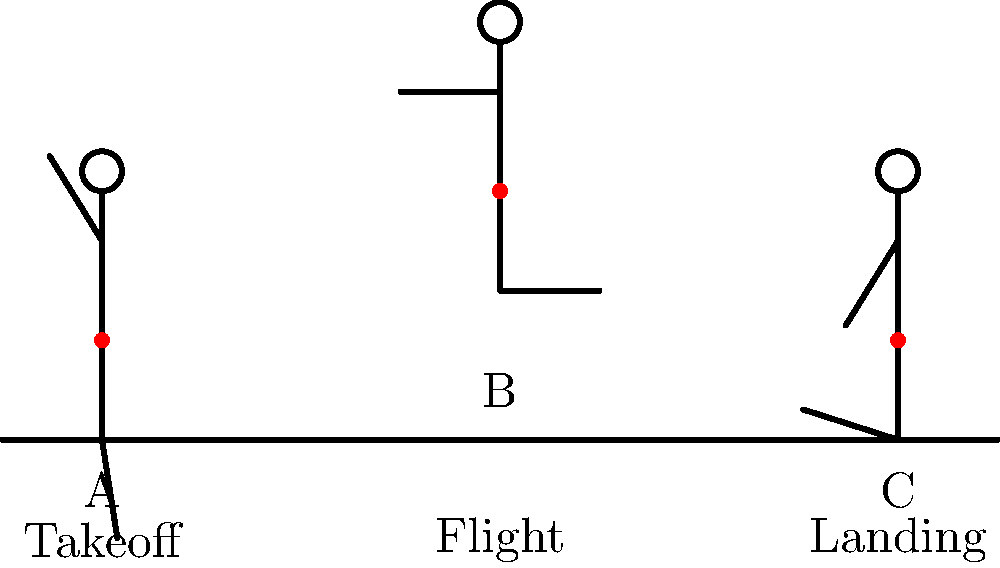In a long jump, the athlete's center of mass (COM) shifts during different phases of the jump. Referring to the stick figure diagram showing the takeoff (A), flight (B), and landing (C) phases, at which phase is the athlete's COM typically at its highest point relative to the ground? To determine the phase where the athlete's center of mass (COM) is at its highest point, let's analyze each phase:

1. Takeoff (A):
   - The athlete is still in contact with the ground.
   - The COM is relatively low as the athlete is in a crouched position to generate explosive force.

2. Flight (B):
   - The athlete is no longer in contact with the ground.
   - The body is fully extended in the air.
   - The COM is at its highest point relative to the ground during this phase.

3. Landing (C):
   - The athlete is making contact with the ground again.
   - The body is beginning to bend to absorb the impact.
   - The COM is lowering as the athlete prepares for ground contact.

During the flight phase (B), the athlete's body follows a parabolic trajectory determined by the laws of physics, specifically projectile motion. The COM reaches its apex during this phase when the vertical velocity becomes zero momentarily before beginning to descend.

The takeoff and landing phases involve contact with the ground, which naturally keeps the COM closer to the ground level. The flight phase, being free from ground contact, allows the COM to reach its maximum height.

Therefore, the athlete's center of mass is typically at its highest point relative to the ground during the flight phase (B).
Answer: Flight phase (B) 